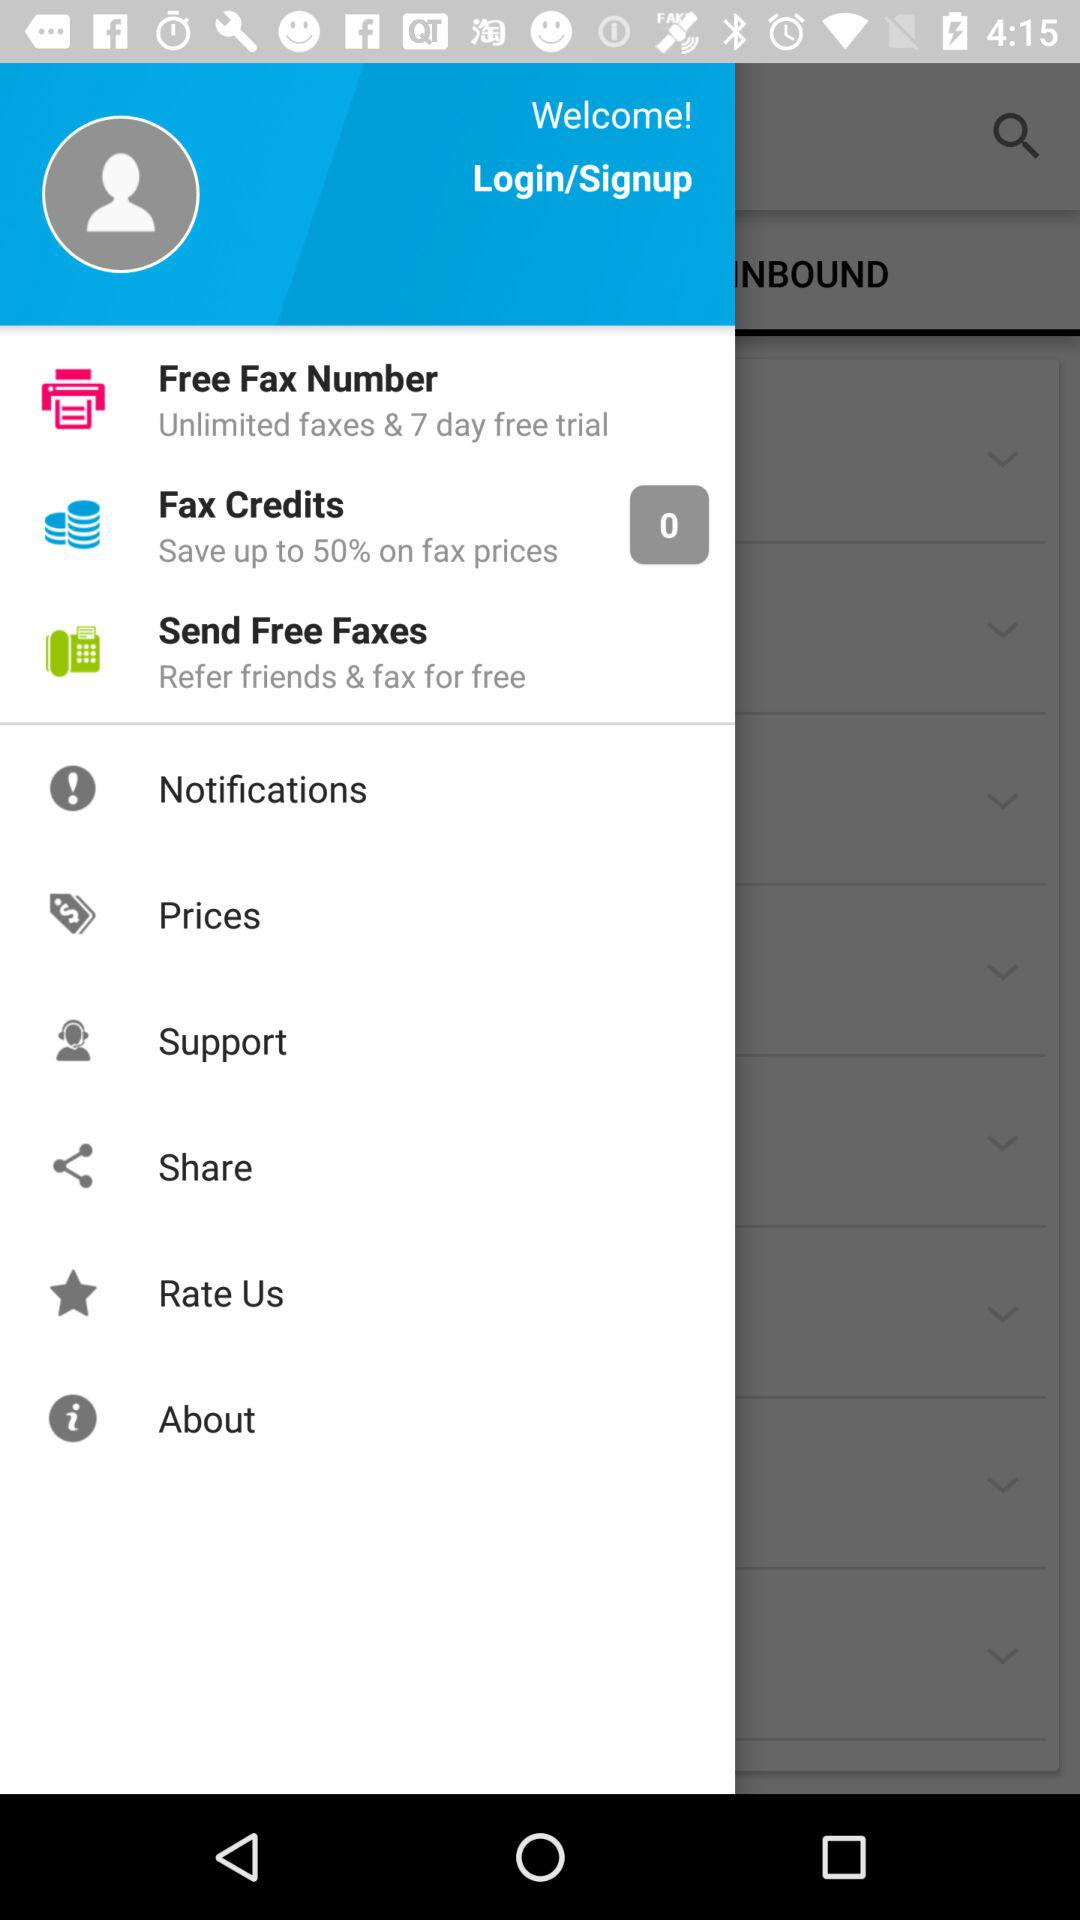For how many days is the free trial for fax number? The free trial is for 7 days. 